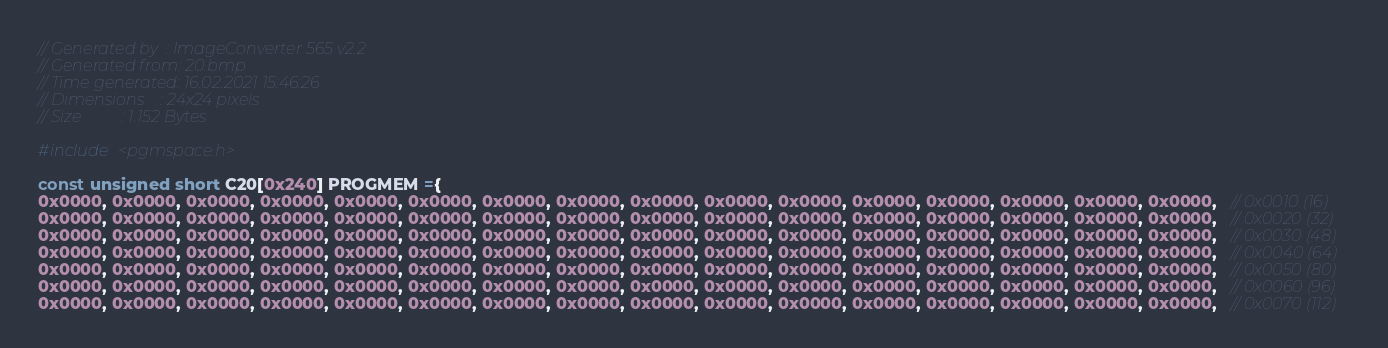<code> <loc_0><loc_0><loc_500><loc_500><_C_>// Generated by  : ImageConverter 565 v2.2
// Generated from: 20.bmp
// Time generated: 16.02.2021 15:46:26
// Dimensions    : 24x24 pixels
// Size          : 1.152 Bytes

#include <pgmspace.h>

const unsigned short C20[0x240] PROGMEM ={
0x0000, 0x0000, 0x0000, 0x0000, 0x0000, 0x0000, 0x0000, 0x0000, 0x0000, 0x0000, 0x0000, 0x0000, 0x0000, 0x0000, 0x0000, 0x0000,   // 0x0010 (16)
0x0000, 0x0000, 0x0000, 0x0000, 0x0000, 0x0000, 0x0000, 0x0000, 0x0000, 0x0000, 0x0000, 0x0000, 0x0000, 0x0000, 0x0000, 0x0000,   // 0x0020 (32)
0x0000, 0x0000, 0x0000, 0x0000, 0x0000, 0x0000, 0x0000, 0x0000, 0x0000, 0x0000, 0x0000, 0x0000, 0x0000, 0x0000, 0x0000, 0x0000,   // 0x0030 (48)
0x0000, 0x0000, 0x0000, 0x0000, 0x0000, 0x0000, 0x0000, 0x0000, 0x0000, 0x0000, 0x0000, 0x0000, 0x0000, 0x0000, 0x0000, 0x0000,   // 0x0040 (64)
0x0000, 0x0000, 0x0000, 0x0000, 0x0000, 0x0000, 0x0000, 0x0000, 0x0000, 0x0000, 0x0000, 0x0000, 0x0000, 0x0000, 0x0000, 0x0000,   // 0x0050 (80)
0x0000, 0x0000, 0x0000, 0x0000, 0x0000, 0x0000, 0x0000, 0x0000, 0x0000, 0x0000, 0x0000, 0x0000, 0x0000, 0x0000, 0x0000, 0x0000,   // 0x0060 (96)
0x0000, 0x0000, 0x0000, 0x0000, 0x0000, 0x0000, 0x0000, 0x0000, 0x0000, 0x0000, 0x0000, 0x0000, 0x0000, 0x0000, 0x0000, 0x0000,   // 0x0070 (112)</code> 